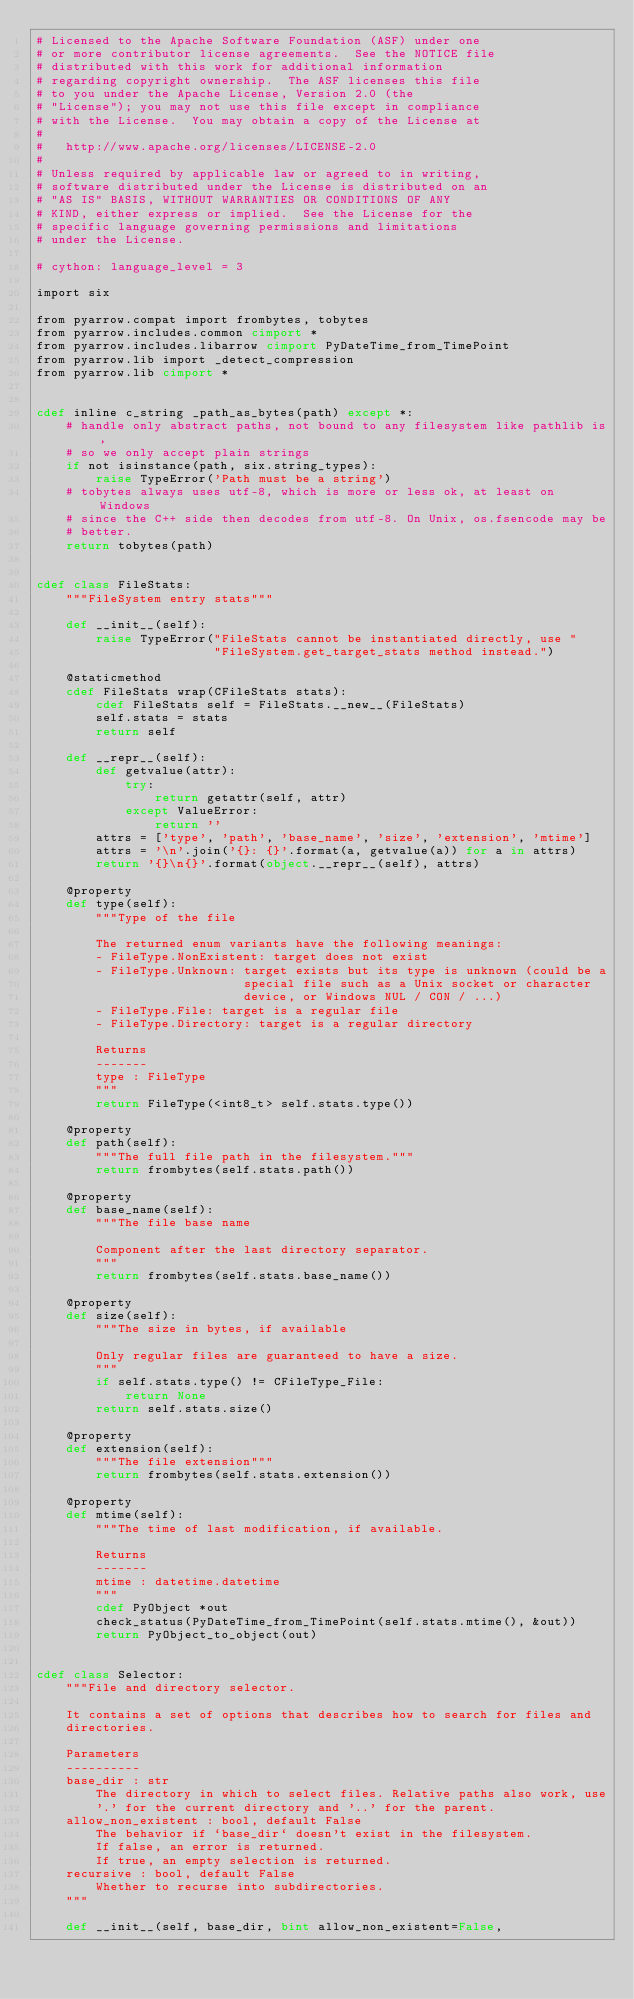<code> <loc_0><loc_0><loc_500><loc_500><_Cython_># Licensed to the Apache Software Foundation (ASF) under one
# or more contributor license agreements.  See the NOTICE file
# distributed with this work for additional information
# regarding copyright ownership.  The ASF licenses this file
# to you under the Apache License, Version 2.0 (the
# "License"); you may not use this file except in compliance
# with the License.  You may obtain a copy of the License at
#
#   http://www.apache.org/licenses/LICENSE-2.0
#
# Unless required by applicable law or agreed to in writing,
# software distributed under the License is distributed on an
# "AS IS" BASIS, WITHOUT WARRANTIES OR CONDITIONS OF ANY
# KIND, either express or implied.  See the License for the
# specific language governing permissions and limitations
# under the License.

# cython: language_level = 3

import six

from pyarrow.compat import frombytes, tobytes
from pyarrow.includes.common cimport *
from pyarrow.includes.libarrow cimport PyDateTime_from_TimePoint
from pyarrow.lib import _detect_compression
from pyarrow.lib cimport *


cdef inline c_string _path_as_bytes(path) except *:
    # handle only abstract paths, not bound to any filesystem like pathlib is,
    # so we only accept plain strings
    if not isinstance(path, six.string_types):
        raise TypeError('Path must be a string')
    # tobytes always uses utf-8, which is more or less ok, at least on Windows
    # since the C++ side then decodes from utf-8. On Unix, os.fsencode may be
    # better.
    return tobytes(path)


cdef class FileStats:
    """FileSystem entry stats"""

    def __init__(self):
        raise TypeError("FileStats cannot be instantiated directly, use "
                        "FileSystem.get_target_stats method instead.")

    @staticmethod
    cdef FileStats wrap(CFileStats stats):
        cdef FileStats self = FileStats.__new__(FileStats)
        self.stats = stats
        return self

    def __repr__(self):
        def getvalue(attr):
            try:
                return getattr(self, attr)
            except ValueError:
                return ''
        attrs = ['type', 'path', 'base_name', 'size', 'extension', 'mtime']
        attrs = '\n'.join('{}: {}'.format(a, getvalue(a)) for a in attrs)
        return '{}\n{}'.format(object.__repr__(self), attrs)

    @property
    def type(self):
        """Type of the file

        The returned enum variants have the following meanings:
        - FileType.NonExistent: target does not exist
        - FileType.Unknown: target exists but its type is unknown (could be a
                            special file such as a Unix socket or character
                            device, or Windows NUL / CON / ...)
        - FileType.File: target is a regular file
        - FileType.Directory: target is a regular directory

        Returns
        -------
        type : FileType
        """
        return FileType(<int8_t> self.stats.type())

    @property
    def path(self):
        """The full file path in the filesystem."""
        return frombytes(self.stats.path())

    @property
    def base_name(self):
        """The file base name

        Component after the last directory separator.
        """
        return frombytes(self.stats.base_name())

    @property
    def size(self):
        """The size in bytes, if available

        Only regular files are guaranteed to have a size.
        """
        if self.stats.type() != CFileType_File:
            return None
        return self.stats.size()

    @property
    def extension(self):
        """The file extension"""
        return frombytes(self.stats.extension())

    @property
    def mtime(self):
        """The time of last modification, if available.

        Returns
        -------
        mtime : datetime.datetime
        """
        cdef PyObject *out
        check_status(PyDateTime_from_TimePoint(self.stats.mtime(), &out))
        return PyObject_to_object(out)


cdef class Selector:
    """File and directory selector.

    It contains a set of options that describes how to search for files and
    directories.

    Parameters
    ----------
    base_dir : str
        The directory in which to select files. Relative paths also work, use
        '.' for the current directory and '..' for the parent.
    allow_non_existent : bool, default False
        The behavior if `base_dir` doesn't exist in the filesystem.
        If false, an error is returned.
        If true, an empty selection is returned.
    recursive : bool, default False
        Whether to recurse into subdirectories.
    """

    def __init__(self, base_dir, bint allow_non_existent=False,</code> 